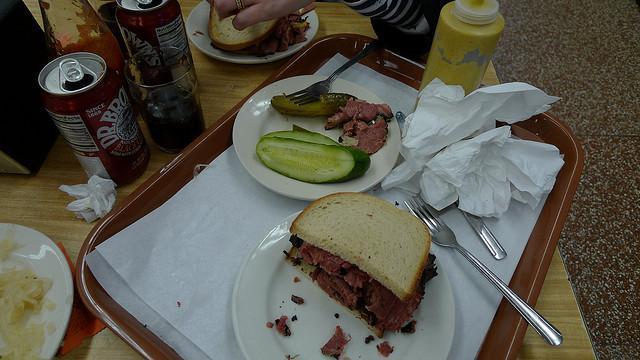How many sandwiches are there?
Give a very brief answer. 2. 